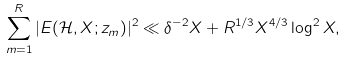<formula> <loc_0><loc_0><loc_500><loc_500>\sum _ { m = 1 } ^ { R } | E ( \mathcal { H } , X ; z _ { m } ) | ^ { 2 } \ll \delta ^ { - 2 } X + R ^ { 1 / 3 } X ^ { 4 / 3 } \log ^ { 2 } X ,</formula> 